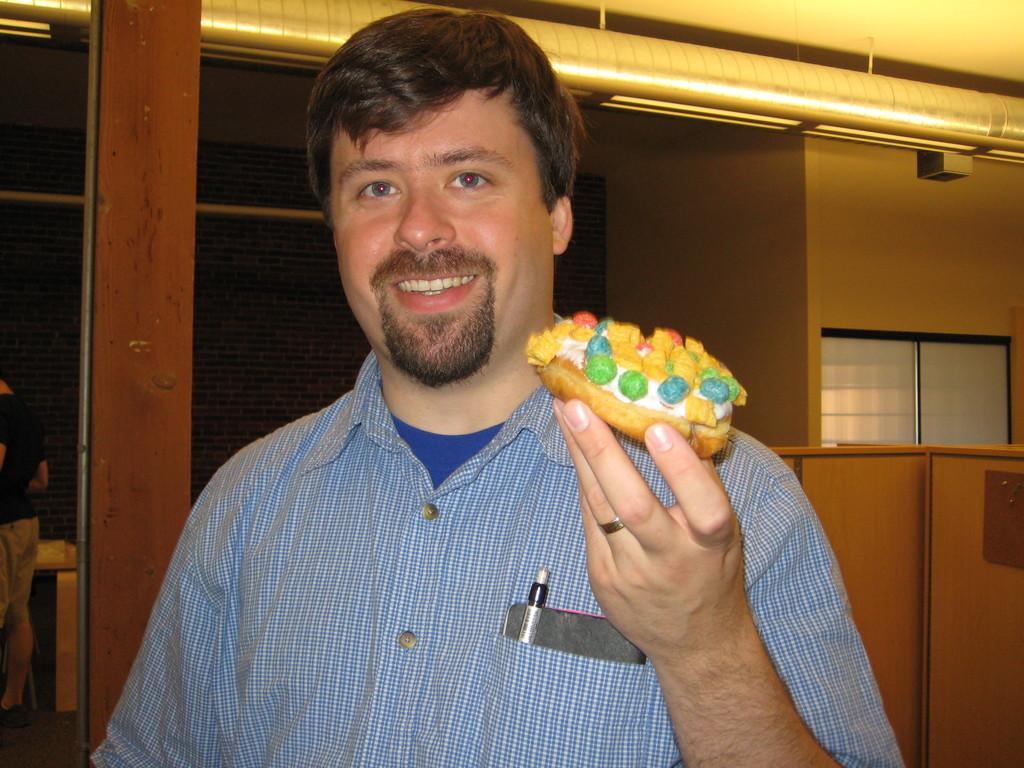How would you summarize this image in a sentence or two? In this image we can see a person wearing blue color dress standing and holding some doughnut in his hands and there is a mobile phone and pen in his pocket and in the background of the image there is a wall and vent pipes, on left side of the image there is a person standing near the wall. 